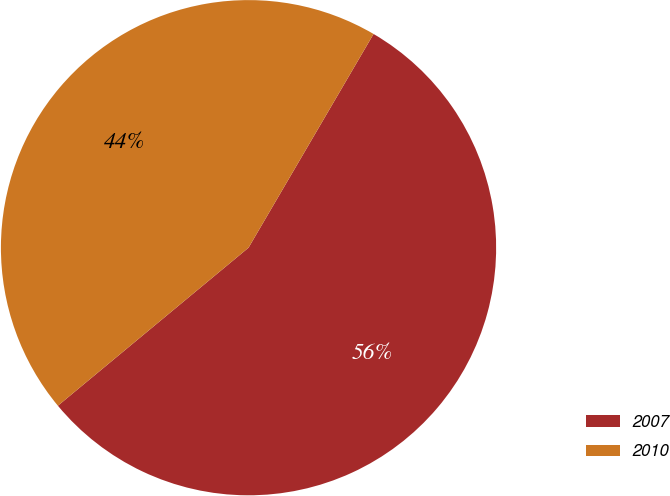<chart> <loc_0><loc_0><loc_500><loc_500><pie_chart><fcel>2007<fcel>2010<nl><fcel>55.56%<fcel>44.44%<nl></chart> 